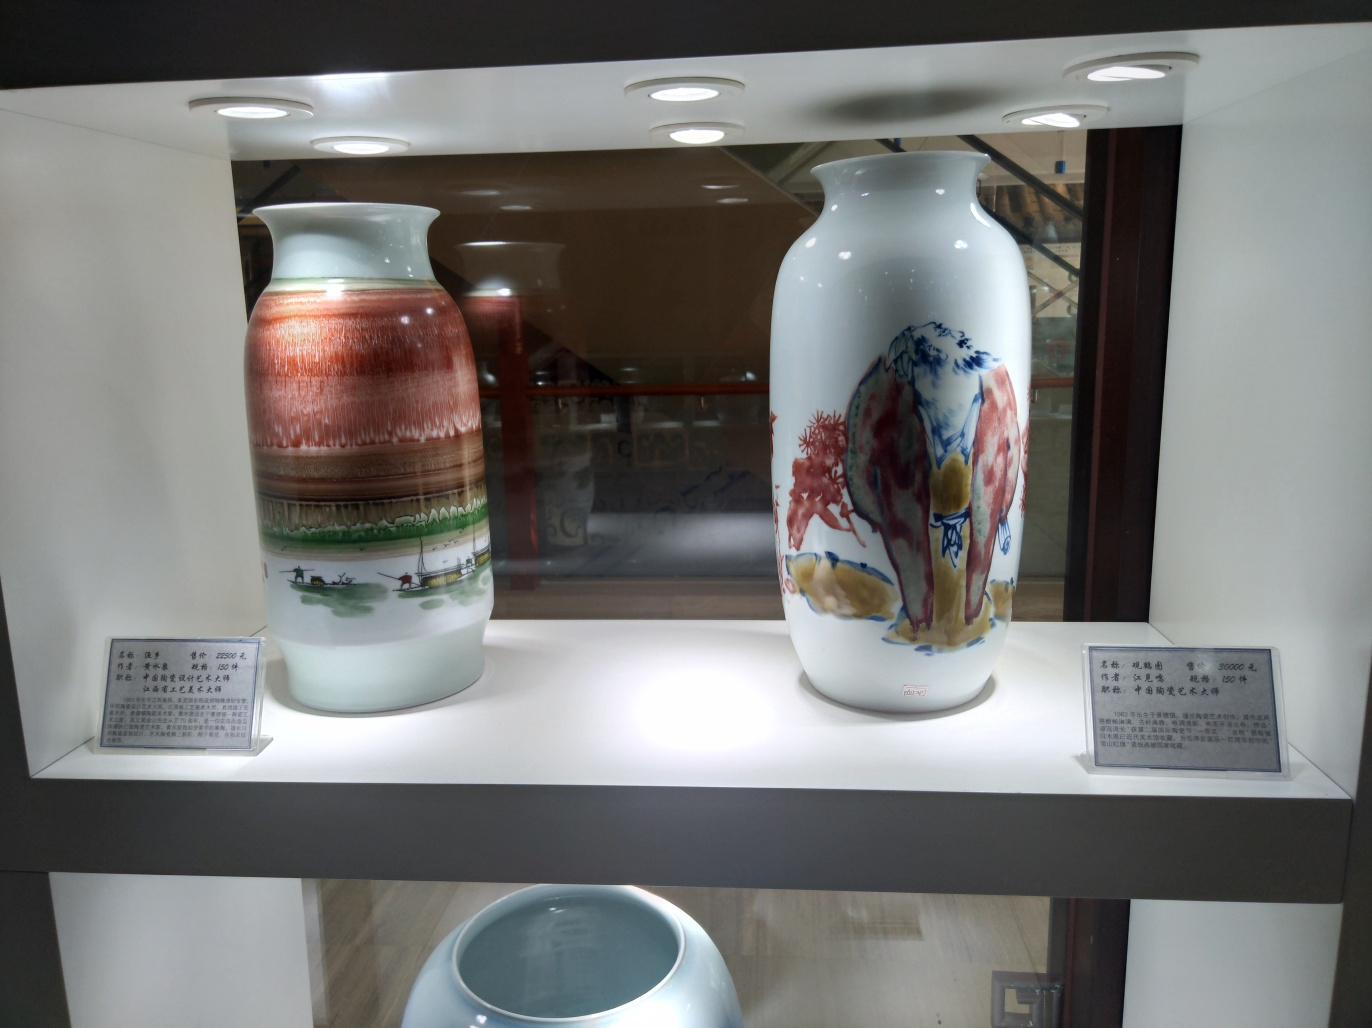Are there any quality issues with this image? The image provided shows two vases under a display light, with each vase accompanied by a small placard. There are a few quality issues with this image: the photo is slightly overexposed due to the direct lighting from above, causing reflections on the vases and a loss of detail in the highlights. Additionally, the angle of the shot results in a perspective distortion making the closer objects appear disproportionately large relative to the ones farther away. A better quality image could minimize these reflections and correct perspective distortions to provide a clearer view of the vases and their details. 